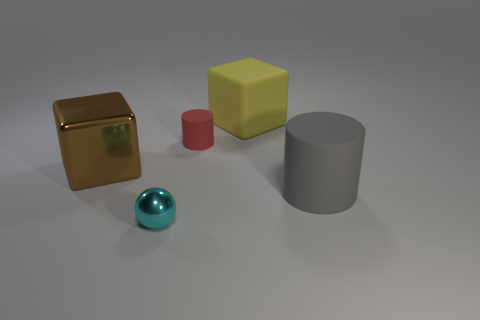How many cyan objects are big metallic objects or metal balls?
Make the answer very short. 1. The gray object that is made of the same material as the yellow block is what size?
Your answer should be very brief. Large. How many tiny metallic objects are the same shape as the large metal thing?
Keep it short and to the point. 0. Is the number of red matte things in front of the red rubber cylinder greater than the number of big brown objects to the right of the cyan object?
Provide a short and direct response. No. Do the shiny block and the rubber cylinder that is behind the big brown cube have the same color?
Provide a short and direct response. No. There is a block that is the same size as the brown thing; what is its material?
Your response must be concise. Rubber. How many things are either small gray shiny cylinders or objects in front of the gray cylinder?
Your answer should be compact. 1. Do the yellow block and the rubber object in front of the tiny red thing have the same size?
Your answer should be compact. Yes. What number of spheres are either small red things or brown objects?
Provide a short and direct response. 0. How many things are both left of the large cylinder and in front of the brown metallic object?
Provide a succinct answer. 1. 